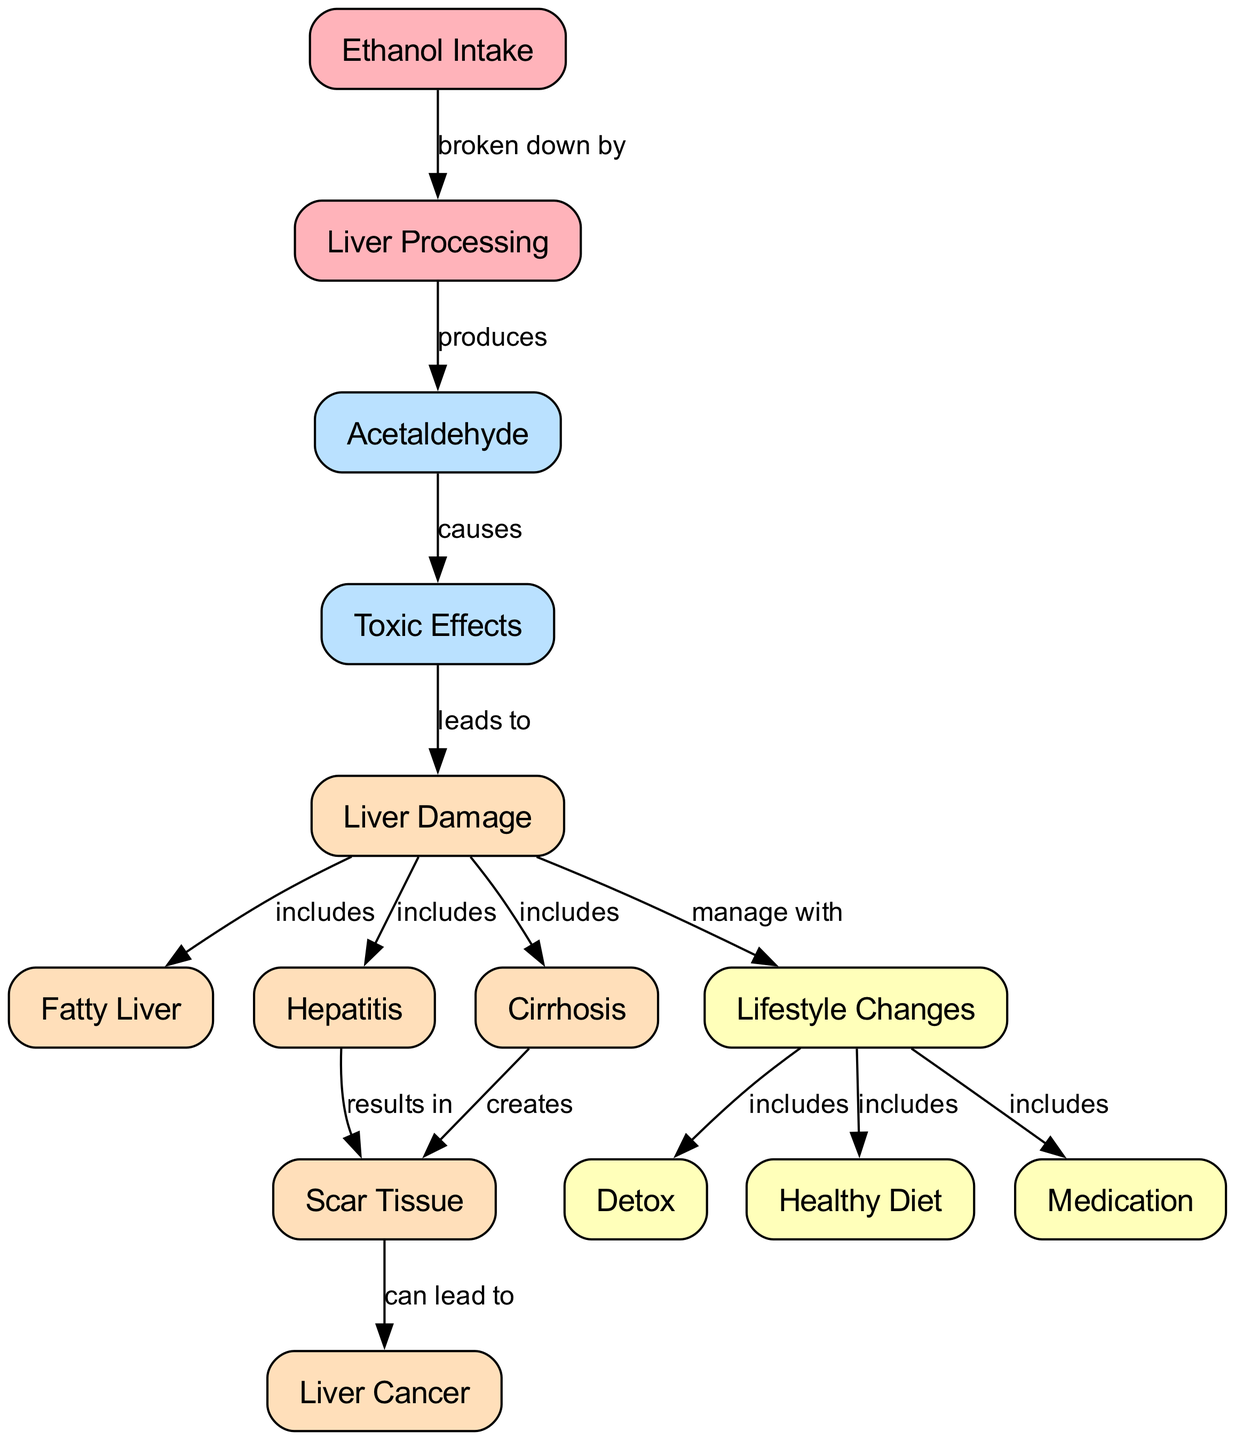what node directly follows Ethanol Intake? According to the diagram, Ethanol Intake flows into the next step, which is Liver Processing. This can be identified as the next node linked from Ethanol Intake.
Answer: Liver Processing how many total nodes are in the diagram? The diagram lists a total of 14 distinctive nodes, including factors related to Ethanol Intake, its processing, toxic effects, various types of liver damage, and lifestyle changes that can manage the effects.
Answer: 14 which node results from Hepatitis? Hepatitis leads to the formation of Scar Tissue as indicated by the directed flow from the Hepatitis node to the Scar Tissue node in the diagram.
Answer: Scar Tissue what connection does Acetaldehyde have? Acetaldehyde is connected to Toxic Effects, as shown in the diagram where Acetaldehyde causes Toxic Effects. This relationship indicates the adverse impact Acetaldehyde has after liver processing.
Answer: causes if liver damage occurs, what can be included to manage it? The diagram specifies that Lifestyle Changes can be implemented to manage Liver Damage. Lifestyle Changes encompass various options, such as Detox, Healthy Diet, and Medication.
Answer: Lifestyle Changes what can result from Cirrhosis? The flow in the diagram indicates that Cirrhosis can create Scar Tissue, as seen in the directed edge showing the relationship between these two nodes.
Answer: Scar Tissue what are two effects included under Liver Damage? The two effects illustrated under Liver Damage in the diagram are Fatty Liver and Hepatitis, both of which are connected to the Liver Damage node.
Answer: Fatty Liver, Hepatitis which stage directly produces Acetaldehyde? The process that directly produces Acetaldehyde is Liver Processing, as indicated by the flow from the Liver Processing node to the Acetaldehyde node in the diagram.
Answer: Liver Processing how can lifestyle changes help with liver health? Lifestyle Changes serve to manage Liver Damage by introducing healthier habits and options, which are depicted in the flow from Liver Damage to the Lifestyle Changes node.
Answer: manage with 